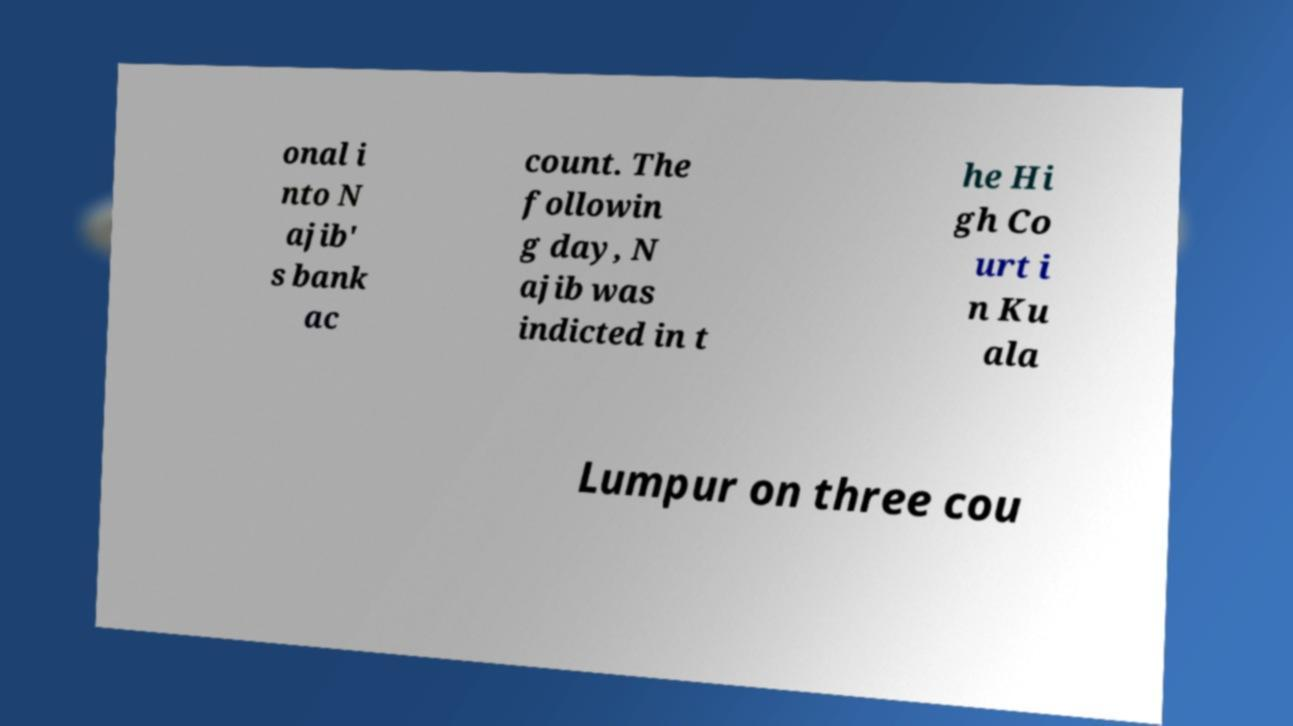Please identify and transcribe the text found in this image. onal i nto N ajib' s bank ac count. The followin g day, N ajib was indicted in t he Hi gh Co urt i n Ku ala Lumpur on three cou 